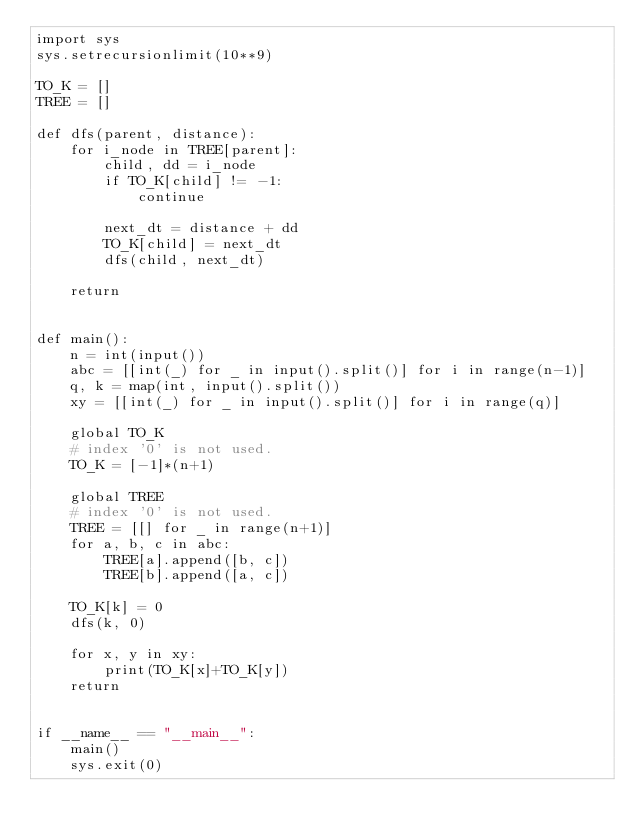<code> <loc_0><loc_0><loc_500><loc_500><_Python_>import sys
sys.setrecursionlimit(10**9)

TO_K = []
TREE = []

def dfs(parent, distance):
    for i_node in TREE[parent]:
        child, dd = i_node
        if TO_K[child] != -1:
            continue

        next_dt = distance + dd
        TO_K[child] = next_dt
        dfs(child, next_dt)

    return


def main():
    n = int(input())
    abc = [[int(_) for _ in input().split()] for i in range(n-1)]
    q, k = map(int, input().split())
    xy = [[int(_) for _ in input().split()] for i in range(q)]

    global TO_K
    # index '0' is not used.
    TO_K = [-1]*(n+1)

    global TREE
    # index '0' is not used.
    TREE = [[] for _ in range(n+1)]
    for a, b, c in abc:
        TREE[a].append([b, c])
        TREE[b].append([a, c])

    TO_K[k] = 0
    dfs(k, 0)

    for x, y in xy:
        print(TO_K[x]+TO_K[y])
    return


if __name__ == "__main__":
    main()
    sys.exit(0)</code> 